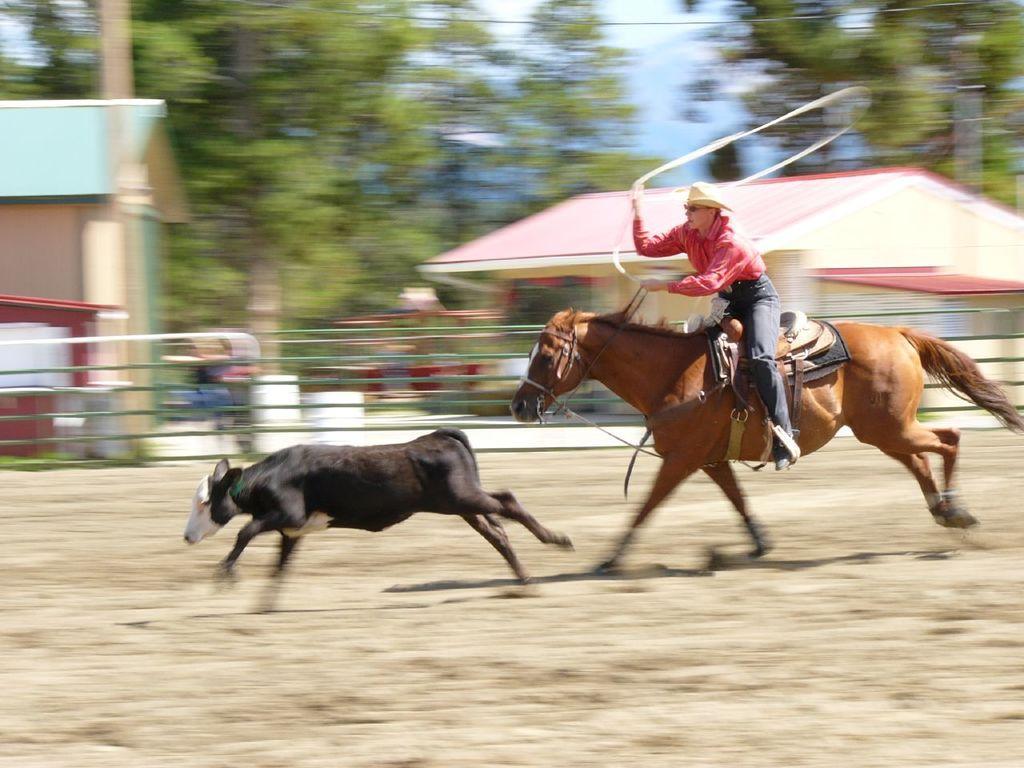In one or two sentences, can you explain what this image depicts? In this image we can see an animal running. Also there is a person wearing hat and goggles. He is riding on a horse. He is holding something in the hand. In the back it is looking blur. And there is a fencing. Also there are buildings and trees. 